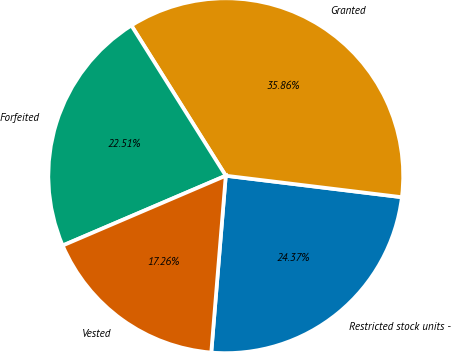Convert chart to OTSL. <chart><loc_0><loc_0><loc_500><loc_500><pie_chart><fcel>Restricted stock units -<fcel>Granted<fcel>Forfeited<fcel>Vested<nl><fcel>24.37%<fcel>35.86%<fcel>22.51%<fcel>17.26%<nl></chart> 